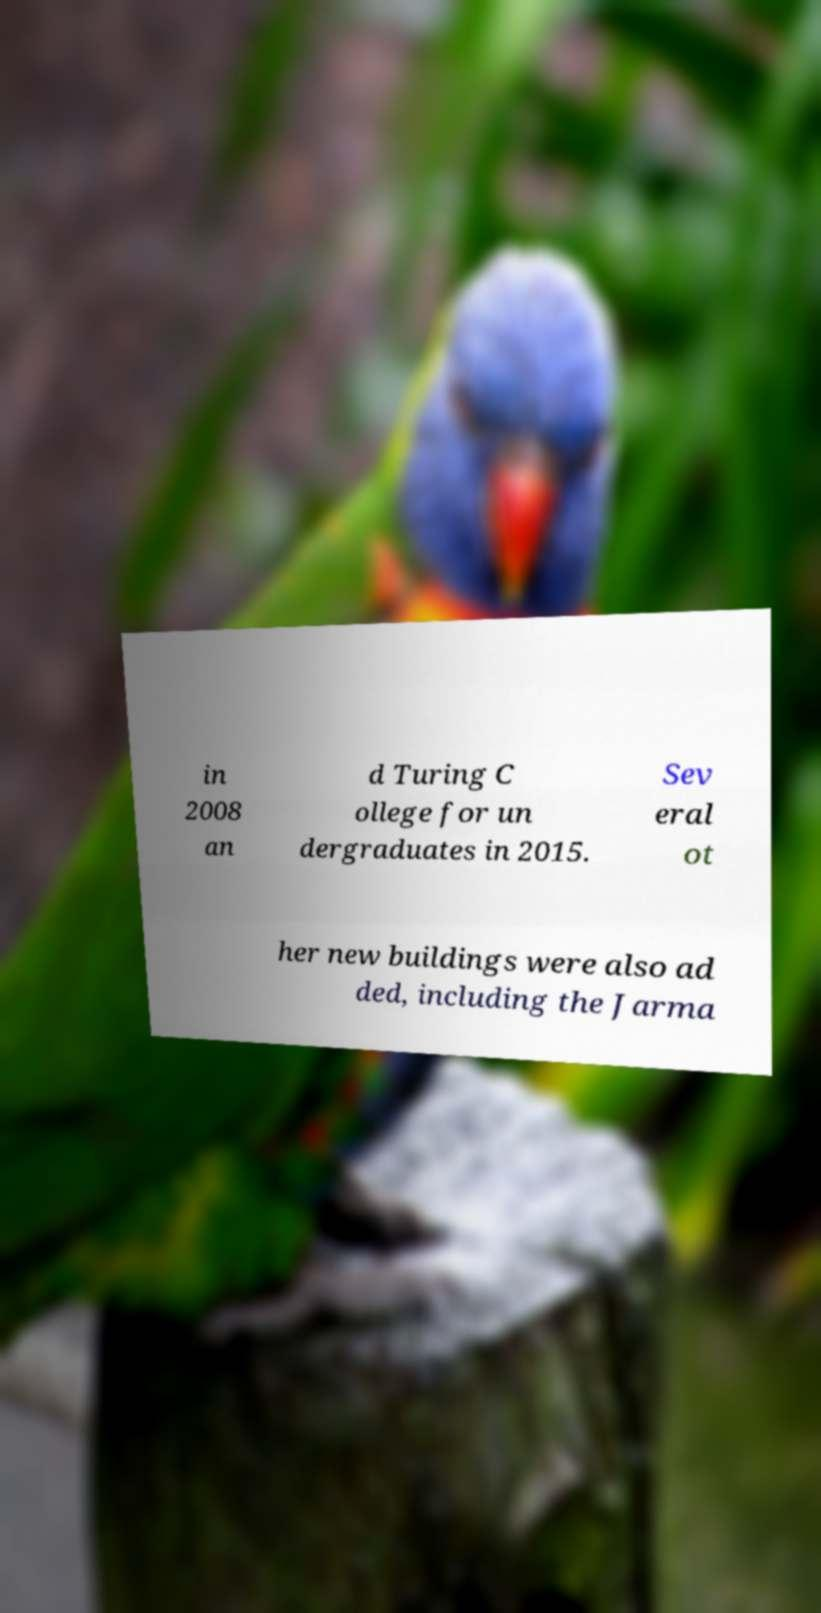I need the written content from this picture converted into text. Can you do that? in 2008 an d Turing C ollege for un dergraduates in 2015. Sev eral ot her new buildings were also ad ded, including the Jarma 